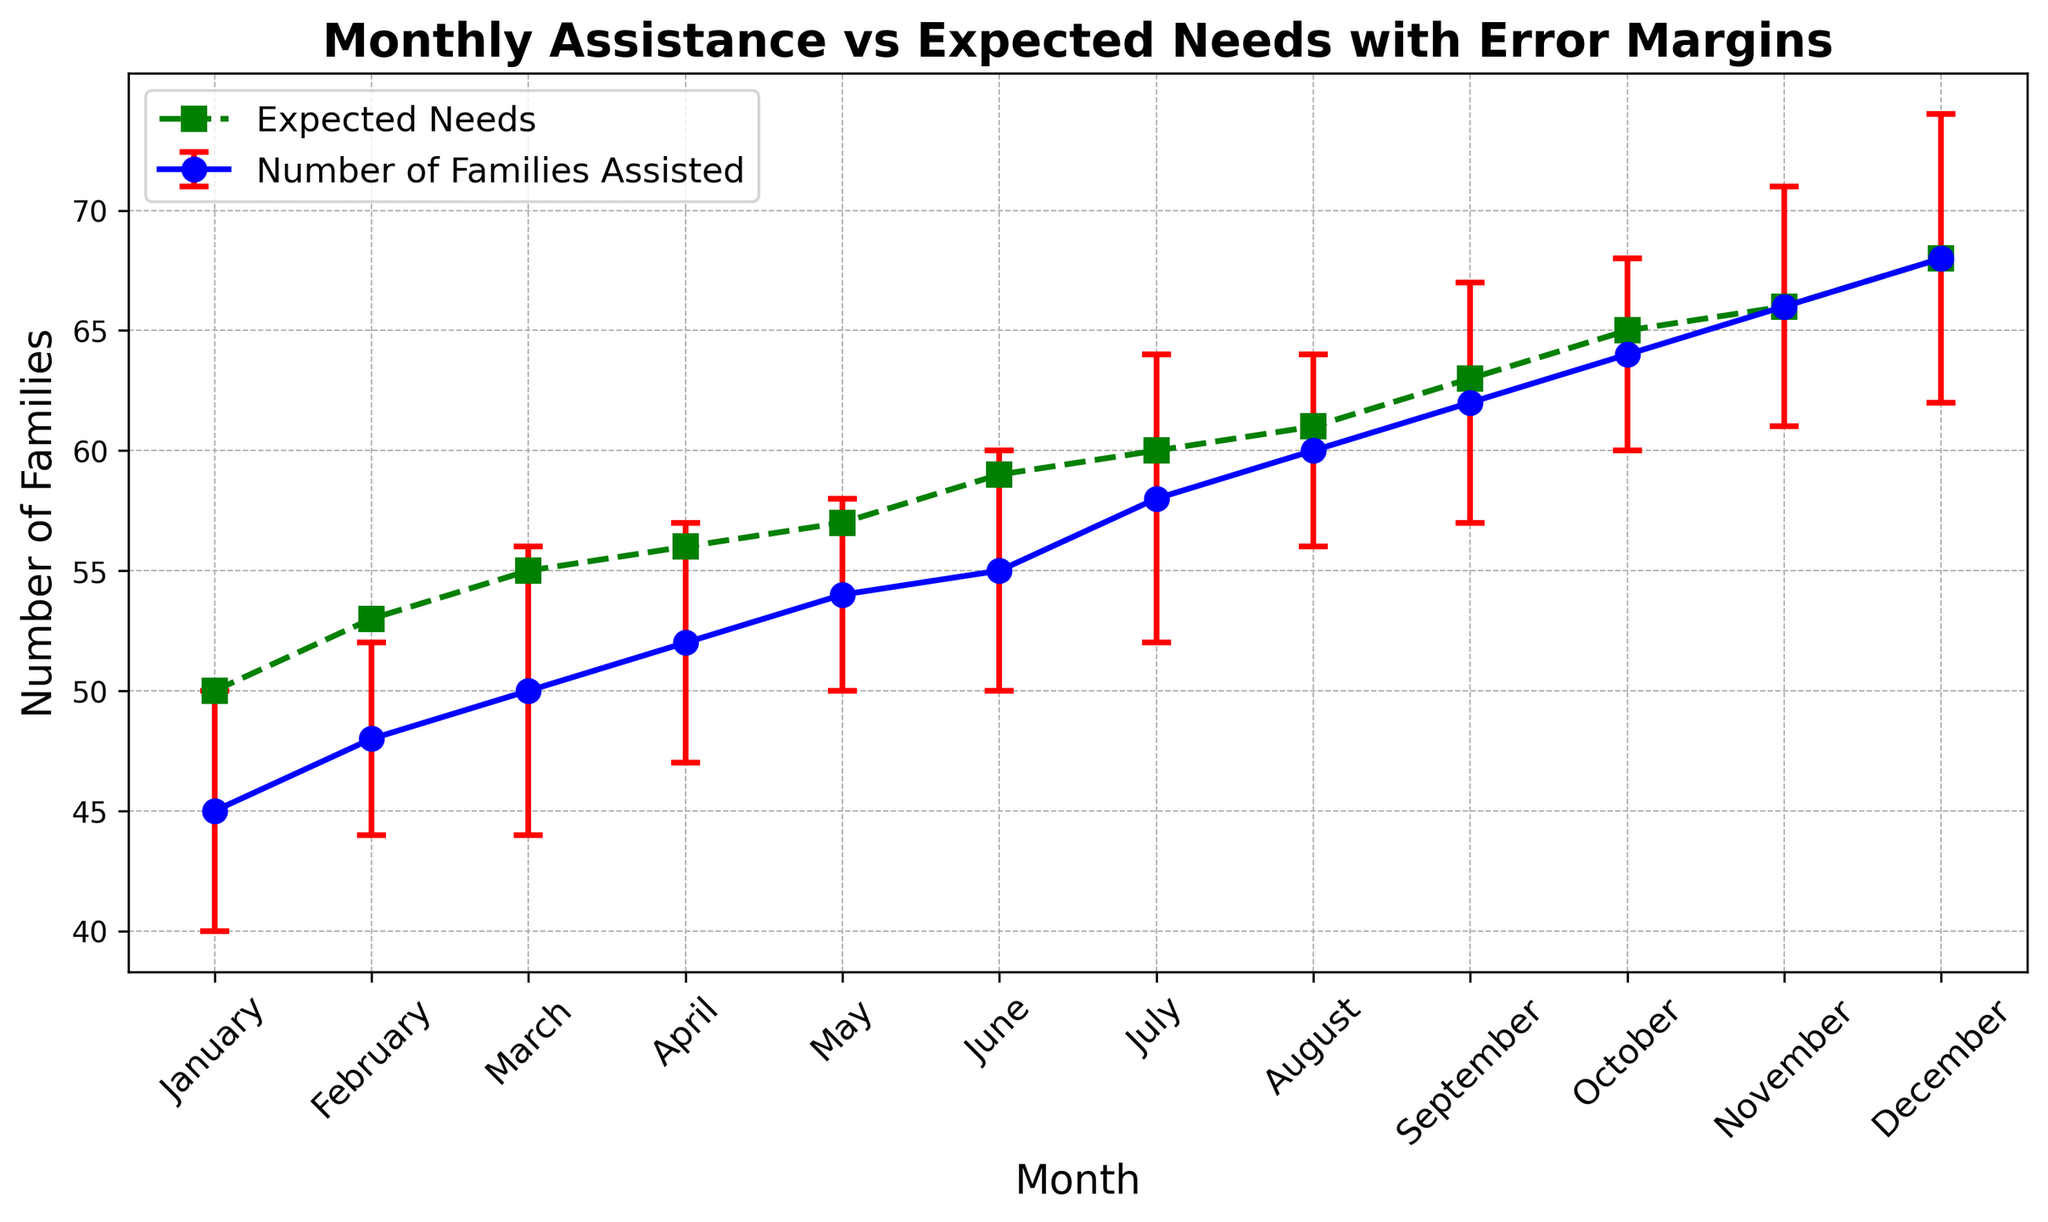What's the average number of families assisted from January to June? The numbers are 45, 48, 50, 52, 54, and 55. Sum these up (45 + 48 + 50 + 52 + 54 + 55) = 304, then divide by 6. 304 / 6 = 50.67
Answer: 50.67 In which month is the actual number of families assisted equal to the expected needs? November shows 66 families assisted and 66 expected needs. Verify this by checking specific values in November.
Answer: November Which months show a deviation where the families assisted are lower than the expected needs when considering the error margin? Compare the Number of Families Assisted with the Expected Needs factoring in the error margin for each month. After checking:
January: 45 + 5 = 50 = 50,
February: 48 + 4 = 52 < 53,
March: 50 + 6 = 56 < 55,
April: 52 + 5 = 57 < 56,
May: 54 + 4 = 58 < 57,
June: 55 + 5 = 60 < 59,
July: 58 + 6 = 64 < 60,
August: 60 + 4 = 64 < 61,
September: 62 + 5 = 67 < 63,
October: 64 + 4 = 68 < 65,
November = December: 66, 68. The months are March, April, and May.
Answer: March, April, May How does the pattern of the number of families assisted compare to the pattern of expected needs over the year? Both trends are generally increasing, starting from the lowest numbers in January and slowly rising to reach their peak in December. However, the number of families assisted is consistently slightly lower than the expected needs.
Answer: Both trends increase, with assists consistently slightly lower than needs What is the difference between the highest and lowest number of families assisted? The highest is in December with 68 families and the lowest is in January with 45 families. The difference is 68 - 45 = 23.
Answer: 23 